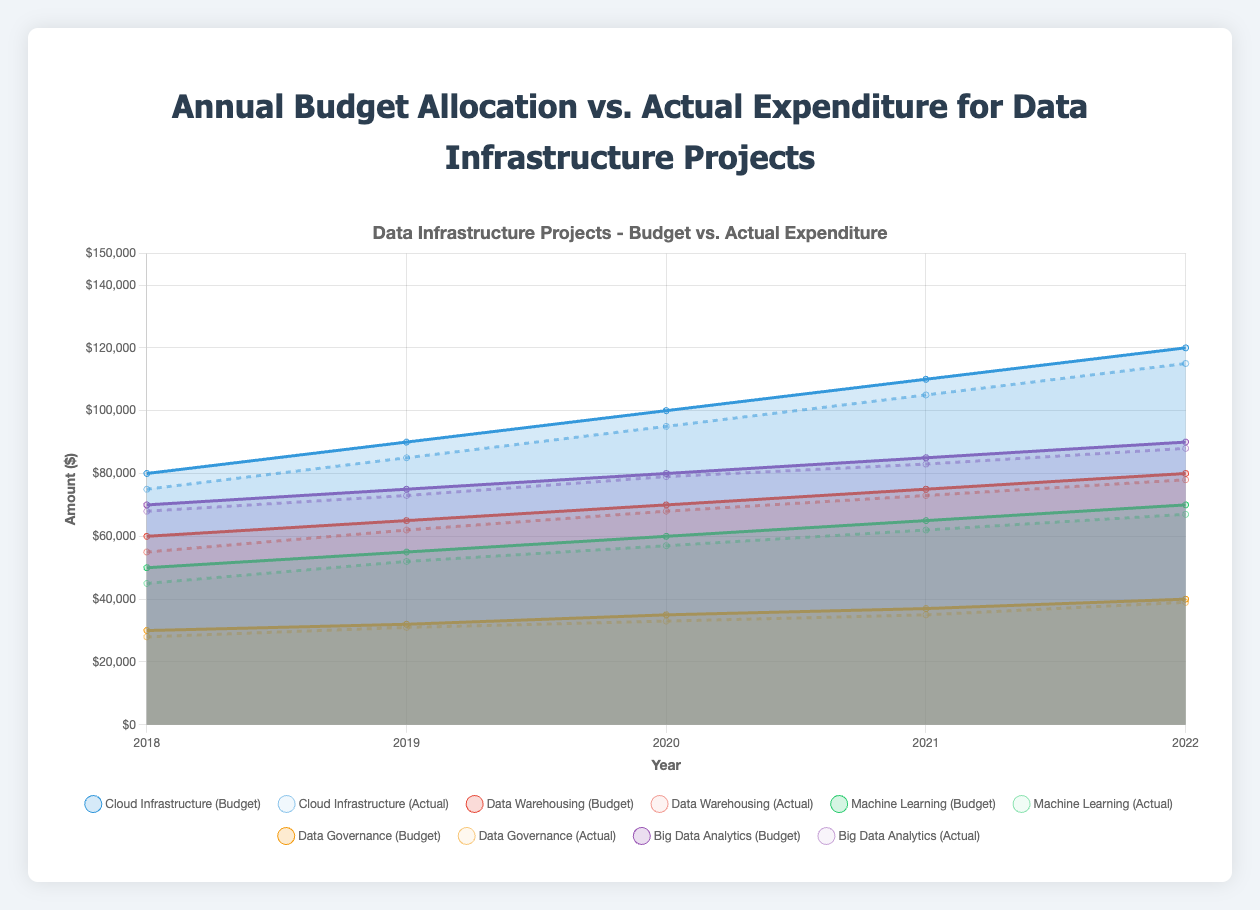what does the figure's title indicate? The title "Annual Budget Allocation vs. Actual Expenditure for Data Infrastructure Projects" indicates that the figure compares the planned budget allocation versus the actual spending for various data infrastructure projects from 2018 to 2022.
Answer: It indicates a comparison of budget plans and actual spendings Which project had the highest actual expenditure in 2022? To find this, we compare the actual expenditure values for all projects in 2022: Cloud Infrastructure ($115,000), Data Warehousing ($78,000), Machine Learning ($67,000), Data Governance ($39,000), and Big Data Analytics ($88,000). Cloud Infrastructure had the highest actual expenditure.
Answer: Cloud Infrastructure Which year witnessed the smallest difference between the budget and actual expenditure for Data Warehousing? By calculating the difference for each year: 2018 ($5,000), 2019 ($3,000), 2020 ($2,000), 2021 ($2,000), 2022 ($2,000), it is clear that the smallest difference occurred in 2020, 2021, and 2022.
Answer: 2020, 2021, and 2022 Was the budget ever exceeded for Machine Learning projects across these years? To determine this, we check if actual expenditure ever exceeds the annual budget for any year: 2018 ($50,000 vs $45,000), 2019 ($55,000 vs $52,000), 2020 ($60,000 vs $57,000), 2021 ($65,000 vs $62,000), 2022 ($70,000 vs $67,000). In all years, actual expenditure is less than the budget.
Answer: No By how much did the actual expenditure for Cloud Infrastructure increase from 2018 to 2022? Subtract the 2018 figure ($75,000) from the 2022 figure ($115,000): $115,000 - $75,000 = $40,000.
Answer: $40,000 Which project consistently spent less than its allocated budget every year? By examining the actual vs budget spending for each project from 2018 to 2022, Machine Learning spent less than the allocated budget every year.
Answer: Machine Learning What is the combined actual expenditure for all projects in 2020? Add the actual expenditures for 2020 across all projects: Cloud Infrastructure ($95,000) + Data Warehousing ($68,000) + Machine Learning ($57,000) + Data Governance ($33,000) + Big Data Analytics ($79,000) = $332,000.
Answer: $332,000 Which year had the highest combined annual budget across all projects? By summing the annual budget for each year: 
2018 ($290,000), 2019 ($317,000), 2020 ($345,000), 2021 ($374,000), 2022 ($400,000), the year 2022 had the highest combined annual budget.
Answer: 2022 For how many projects did the actual expenditure approach the budget in 2021? Compare the actual expenditure and budget for each project in 2021. Most differences are a few thousand dollars, especially close for Data Warehousing (difference $2,000), Machine Learning ($3,000), and Data Governance ($2,000). The total number is 3 projects.
Answer: 3 